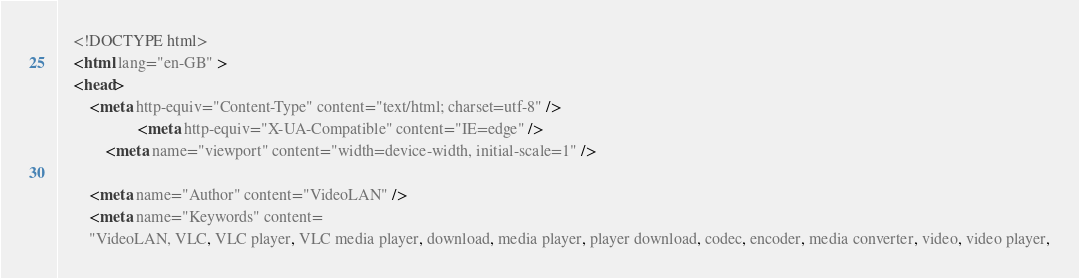<code> <loc_0><loc_0><loc_500><loc_500><_HTML_>    <!DOCTYPE html>
    <html lang="en-GB" >
    <head>
        <meta http-equiv="Content-Type" content="text/html; charset=utf-8" />
                    <meta http-equiv="X-UA-Compatible" content="IE=edge" />
            <meta name="viewport" content="width=device-width, initial-scale=1" />
        
        <meta name="Author" content="VideoLAN" />
        <meta name="Keywords" content=
        "VideoLAN, VLC, VLC player, VLC media player, download, media player, player download, codec, encoder, media converter, video, video player,</code> 